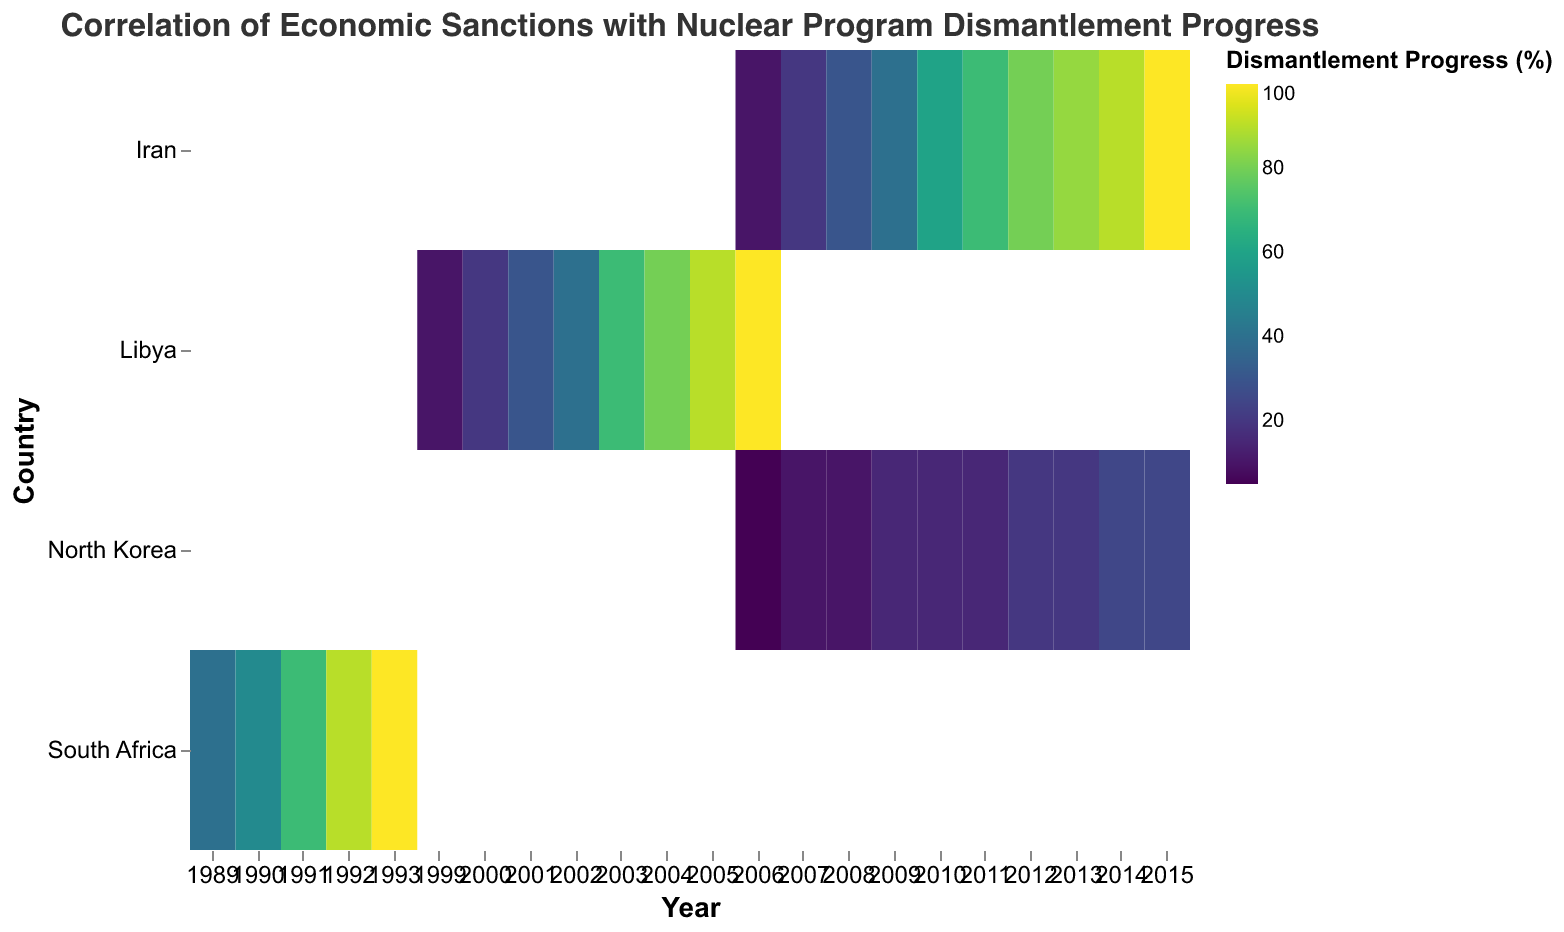What is the title of the heatmap? The title of the heatmap is displayed at the top.
Answer: Correlation of Economic Sanctions with Nuclear Program Dismantlement Progress Which country reached 100% nuclear program dismantlement the earliest? To determine this, examine the years in which each country’s dismantlement progress reached 100%.
Answer: South Africa What is the severity of sanctions in Iran in 2011? Locate Iran for the year 2011 and check the sanctions severity value.
Answer: 8 Compare the dismantlement progress between Iran and North Korea in 2009. Which country shows more progress? Find and compare the dismantlement progress values for Iran and North Korea in 2009.
Answer: Iran What year did Libya's nuclear program dismantlement progress reach 90%? Find the year associated with a 90% dismantlement progress for Libya.
Answer: 2005 Which year had the highest sanctions severity for South Africa? Identify the year with the maximum sanctions severity value for South Africa.
Answer: 1989, 1990, 1991 How does Iran's dismantlement progress change from 2013 to 2014? Observe the dismantlement progress values for Iran between these years and find the difference.
Answer: Increased by 5% What is the average dismantlement progress for Libya from 1999 to 2006? Calculate the average of the dismantlement progress values for Libya over these years.
Answer: 55% Compare the sanctions severity between North Korea and Libya in 2008. Identify the sanctions severity values for both countries in 2008 and compare them.
Answer: Equal (6 for North Korea, 4 for Libya) How does sanctions severity typically relate to nuclear program dismantlement progress based on the heatmap? Observe the general trends across multiple countries to deduce the correlation pattern.
Answer: Generally, higher sanctions severity correlates with higher dismantlement progress over time 